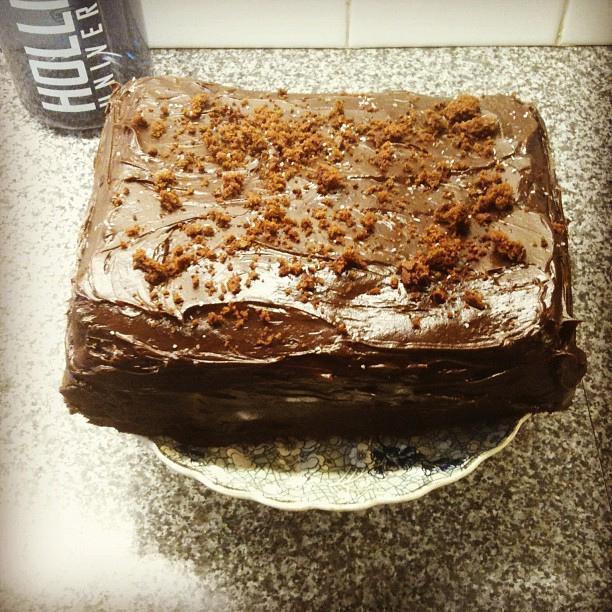What would this food item be ideal for?
Answer the question by selecting the correct answer among the 4 following choices.
Options: Birthday, sweltering day, beach picnic, baseball stadium. Birthday. 